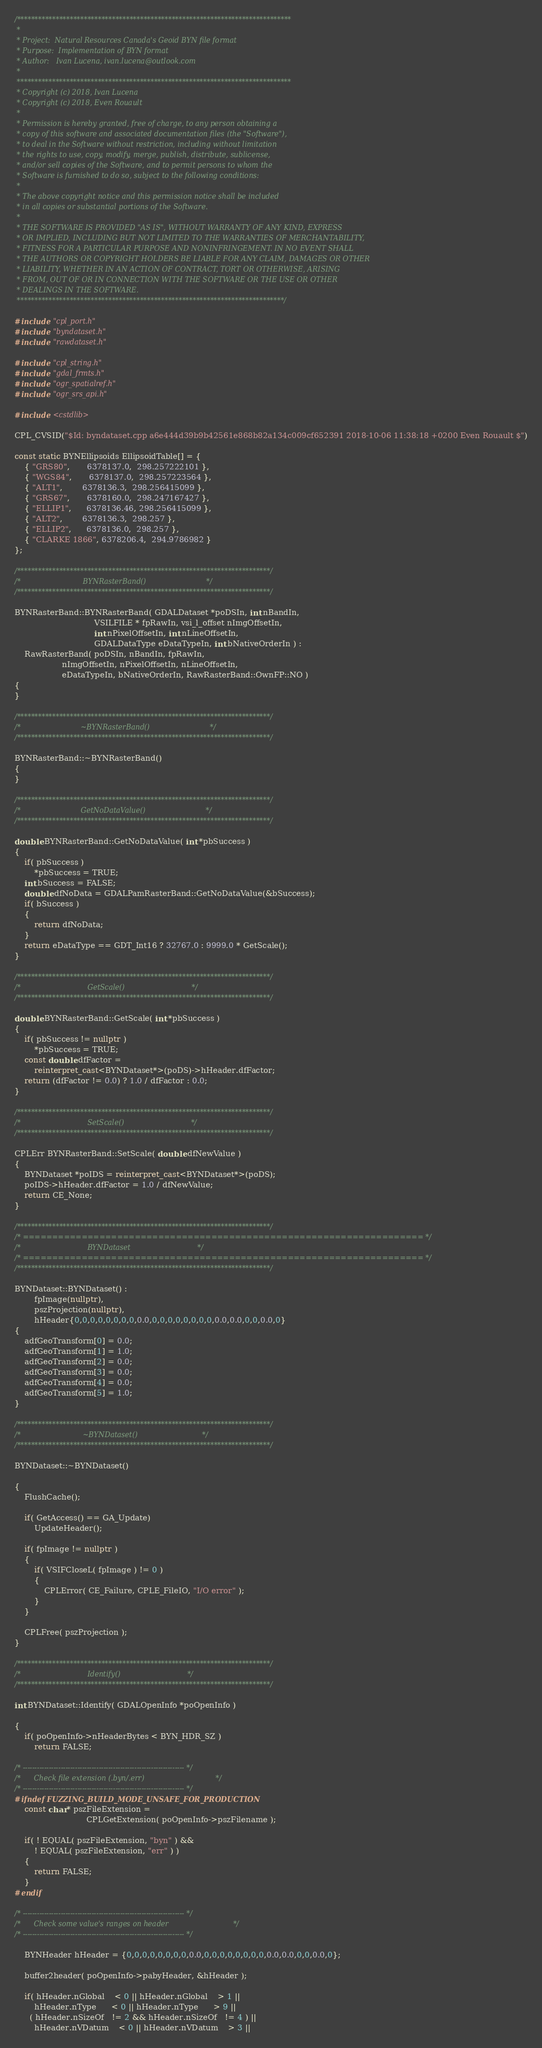Convert code to text. <code><loc_0><loc_0><loc_500><loc_500><_C++_>/******************************************************************************
 *
 * Project:  Natural Resources Canada's Geoid BYN file format
 * Purpose:  Implementation of BYN format
 * Author:   Ivan Lucena, ivan.lucena@outlook.com
 *
 ******************************************************************************
 * Copyright (c) 2018, Ivan Lucena
 * Copyright (c) 2018, Even Rouault
 *
 * Permission is hereby granted, free of charge, to any person obtaining a
 * copy of this software and associated documentation files (the "Software"),
 * to deal in the Software without restriction, including without limitation
 * the rights to use, copy, modify, merge, publish, distribute, sublicense,
 * and/or sell copies of the Software, and to permit persons to whom the
 * Software is furnished to do so, subject to the following conditions:
 *
 * The above copyright notice and this permission notice shall be included
 * in all copies or substantial portions of the Software.
 *
 * THE SOFTWARE IS PROVIDED "AS IS", WITHOUT WARRANTY OF ANY KIND, EXPRESS
 * OR IMPLIED, INCLUDING BUT NOT LIMITED TO THE WARRANTIES OF MERCHANTABILITY,
 * FITNESS FOR A PARTICULAR PURPOSE AND NONINFRINGEMENT. IN NO EVENT SHALL
 * THE AUTHORS OR COPYRIGHT HOLDERS BE LIABLE FOR ANY CLAIM, DAMAGES OR OTHER
 * LIABILITY, WHETHER IN AN ACTION OF CONTRACT, TORT OR OTHERWISE, ARISING
 * FROM, OUT OF OR IN CONNECTION WITH THE SOFTWARE OR THE USE OR OTHER
 * DEALINGS IN THE SOFTWARE.
 ****************************************************************************/

#include "cpl_port.h"
#include "byndataset.h"
#include "rawdataset.h"

#include "cpl_string.h"
#include "gdal_frmts.h"
#include "ogr_spatialref.h"
#include "ogr_srs_api.h"

#include <cstdlib>

CPL_CVSID("$Id: byndataset.cpp a6e444d39b9b42561e868b82a134c009cf652391 2018-10-06 11:38:18 +0200 Even Rouault $")

const static BYNEllipsoids EllipsoidTable[] = {
    { "GRS80",       6378137.0,  298.257222101 },
    { "WGS84",       6378137.0,  298.257223564 },
    { "ALT1",        6378136.3,  298.256415099 },
    { "GRS67",       6378160.0,  298.247167427 },
    { "ELLIP1",      6378136.46, 298.256415099 },
    { "ALT2",        6378136.3,  298.257 },
    { "ELLIP2",      6378136.0,  298.257 },
    { "CLARKE 1866", 6378206.4,  294.9786982 }
};

/************************************************************************/
/*                            BYNRasterBand()                           */
/************************************************************************/

BYNRasterBand::BYNRasterBand( GDALDataset *poDSIn, int nBandIn,
                                VSILFILE * fpRawIn, vsi_l_offset nImgOffsetIn,
                                int nPixelOffsetIn, int nLineOffsetIn,
                                GDALDataType eDataTypeIn, int bNativeOrderIn ) :
    RawRasterBand( poDSIn, nBandIn, fpRawIn,
                   nImgOffsetIn, nPixelOffsetIn, nLineOffsetIn,
                   eDataTypeIn, bNativeOrderIn, RawRasterBand::OwnFP::NO )
{
}

/************************************************************************/
/*                           ~BYNRasterBand()                           */
/************************************************************************/

BYNRasterBand::~BYNRasterBand()
{
}

/************************************************************************/
/*                           GetNoDataValue()                           */
/************************************************************************/

double BYNRasterBand::GetNoDataValue( int *pbSuccess )
{
    if( pbSuccess )
        *pbSuccess = TRUE;
    int bSuccess = FALSE;
    double dfNoData = GDALPamRasterBand::GetNoDataValue(&bSuccess);
    if( bSuccess )
    {
        return dfNoData;
    }
    return eDataType == GDT_Int16 ? 32767.0 : 9999.0 * GetScale();
}

/************************************************************************/
/*                              GetScale()                              */
/************************************************************************/

double BYNRasterBand::GetScale( int *pbSuccess )
{
    if( pbSuccess != nullptr )
        *pbSuccess = TRUE;
    const double dfFactor =
        reinterpret_cast<BYNDataset*>(poDS)->hHeader.dfFactor;
    return (dfFactor != 0.0) ? 1.0 / dfFactor : 0.0;
}

/************************************************************************/
/*                              SetScale()                              */
/************************************************************************/

CPLErr BYNRasterBand::SetScale( double dfNewValue )
{
    BYNDataset *poIDS = reinterpret_cast<BYNDataset*>(poDS);
    poIDS->hHeader.dfFactor = 1.0 / dfNewValue;
    return CE_None;
}

/************************************************************************/
/* ==================================================================== */
/*                              BYNDataset                              */
/* ==================================================================== */
/************************************************************************/

BYNDataset::BYNDataset() : 
        fpImage(nullptr),
        pszProjection(nullptr),
        hHeader{0,0,0,0,0,0,0,0,0.0,0,0,0,0,0,0,0,0,0.0,0.0,0,0,0.0,0}
{
    adfGeoTransform[0] = 0.0;
    adfGeoTransform[1] = 1.0;
    adfGeoTransform[2] = 0.0;
    adfGeoTransform[3] = 0.0;
    adfGeoTransform[4] = 0.0;
    adfGeoTransform[5] = 1.0;
}

/************************************************************************/
/*                            ~BYNDataset()                             */
/************************************************************************/

BYNDataset::~BYNDataset()

{
    FlushCache();

    if( GetAccess() == GA_Update)
        UpdateHeader();

    if( fpImage != nullptr )
    {
        if( VSIFCloseL( fpImage ) != 0 )
        {
            CPLError( CE_Failure, CPLE_FileIO, "I/O error" );
        }
    }

    CPLFree( pszProjection );
}

/************************************************************************/
/*                              Identify()                              */
/************************************************************************/

int BYNDataset::Identify( GDALOpenInfo *poOpenInfo )

{
    if( poOpenInfo->nHeaderBytes < BYN_HDR_SZ )
        return FALSE;

/* -------------------------------------------------------------------- */
/*      Check file extension (.byn/.err)                                */
/* -------------------------------------------------------------------- */
#ifndef FUZZING_BUILD_MODE_UNSAFE_FOR_PRODUCTION
    const char* pszFileExtension =
                             CPLGetExtension( poOpenInfo->pszFilename );

    if( ! EQUAL( pszFileExtension, "byn" ) &&
        ! EQUAL( pszFileExtension, "err" ) )
    {
        return FALSE;
    }
#endif

/* -------------------------------------------------------------------- */
/*      Check some value's ranges on header                             */
/* -------------------------------------------------------------------- */

    BYNHeader hHeader = {0,0,0,0,0,0,0,0,0.0,0,0,0,0,0,0,0,0,0.0,0.0,0,0,0.0,0};

    buffer2header( poOpenInfo->pabyHeader, &hHeader );

    if( hHeader.nGlobal    < 0 || hHeader.nGlobal    > 1 ||
        hHeader.nType      < 0 || hHeader.nType      > 9 ||
      ( hHeader.nSizeOf   != 2 && hHeader.nSizeOf   != 4 ) ||
        hHeader.nVDatum    < 0 || hHeader.nVDatum    > 3 ||</code> 